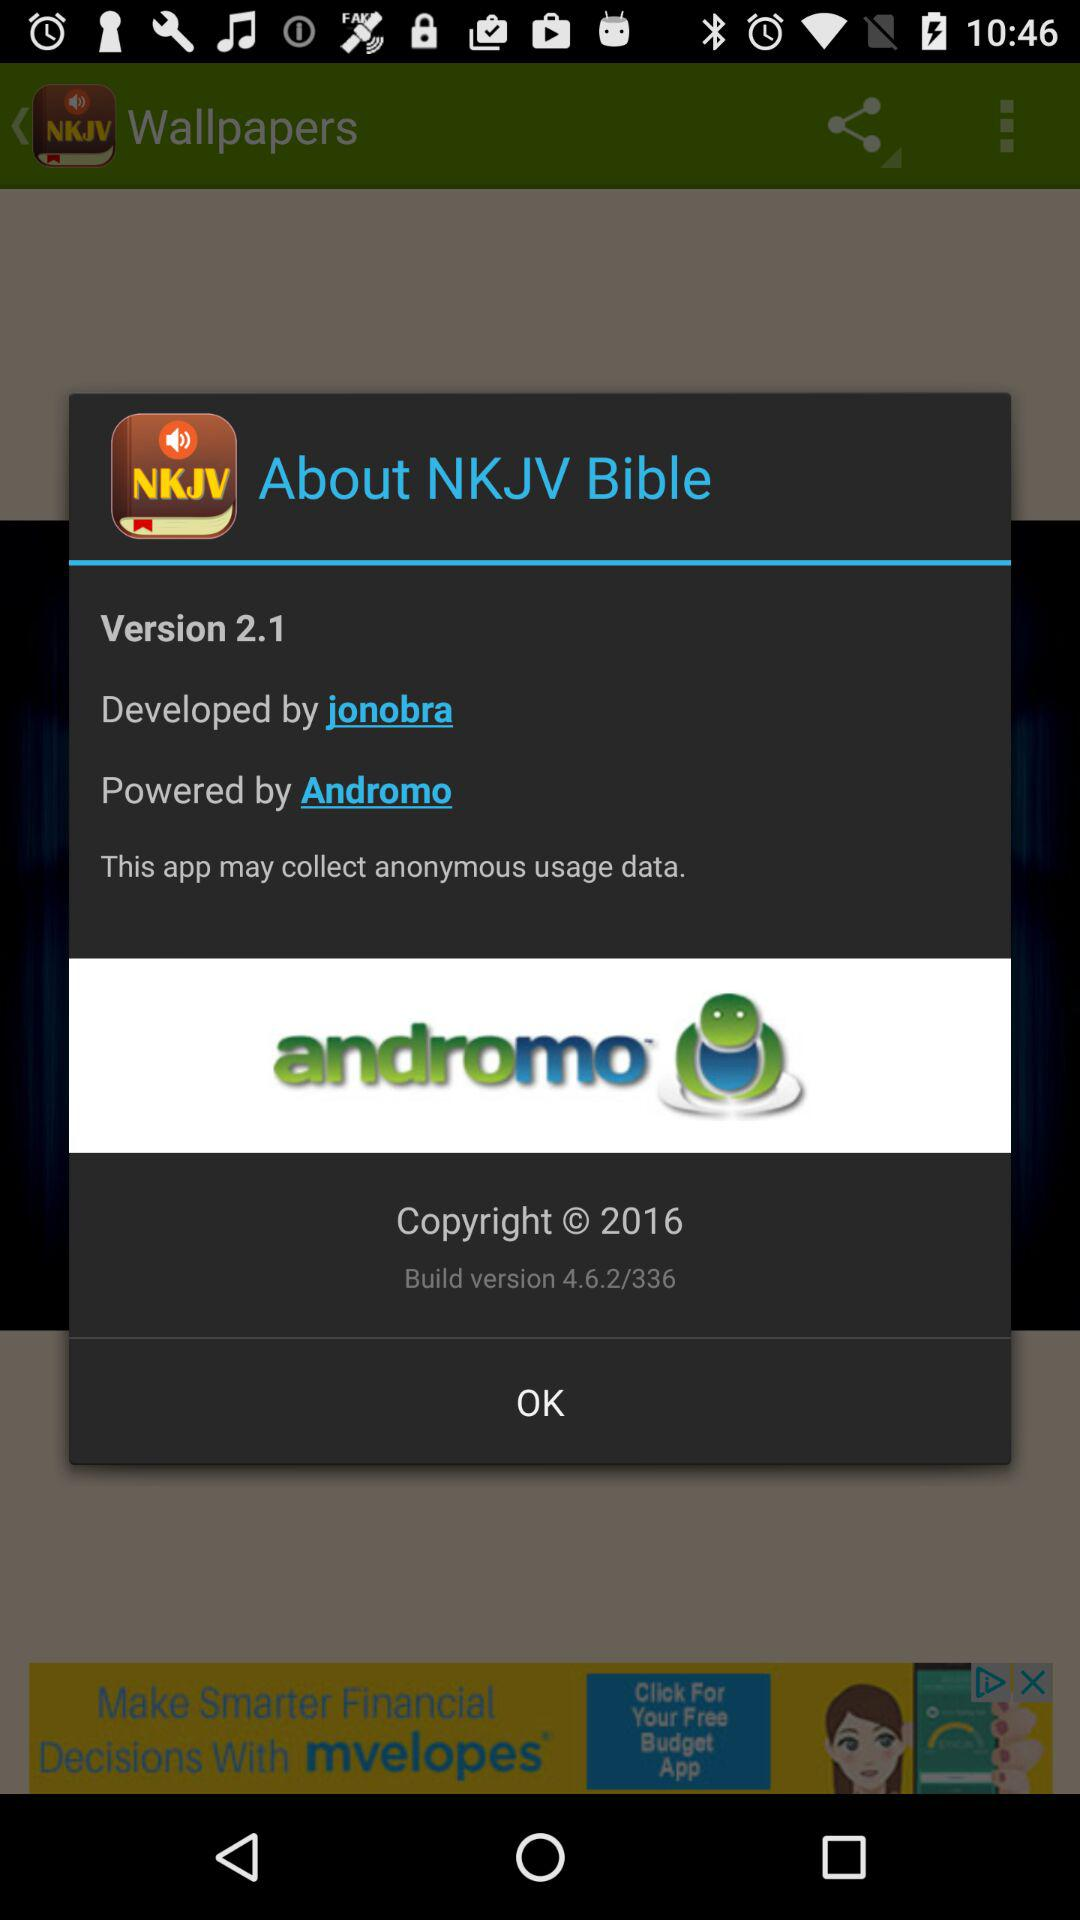What version is used? The version is 2.1. 